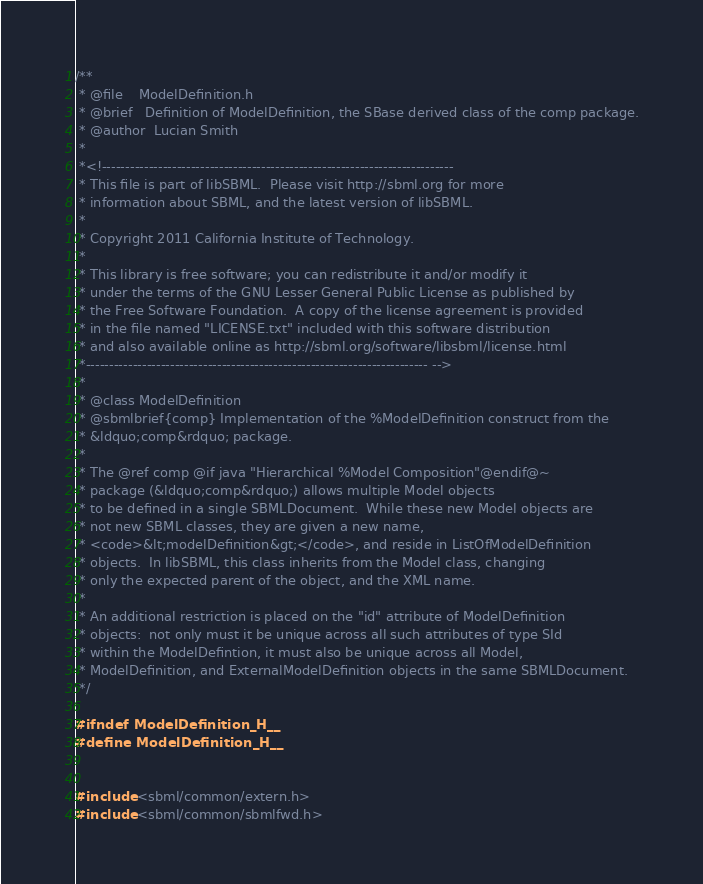<code> <loc_0><loc_0><loc_500><loc_500><_C_>/**
 * @file    ModelDefinition.h
 * @brief   Definition of ModelDefinition, the SBase derived class of the comp package.
 * @author  Lucian Smith 
 *
 *<!---------------------------------------------------------------------------
 * This file is part of libSBML.  Please visit http://sbml.org for more
 * information about SBML, and the latest version of libSBML.
 *
 * Copyright 2011 California Institute of Technology.
 * 
 * This library is free software; you can redistribute it and/or modify it
 * under the terms of the GNU Lesser General Public License as published by
 * the Free Software Foundation.  A copy of the license agreement is provided
 * in the file named "LICENSE.txt" included with this software distribution
 * and also available online as http://sbml.org/software/libsbml/license.html
 *------------------------------------------------------------------------- -->
 *
 * @class ModelDefinition
 * @sbmlbrief{comp} Implementation of the %ModelDefinition construct from the
 * &ldquo;comp&rdquo; package.
 *
 * The @ref comp @if java "Hierarchical %Model Composition"@endif@~ 
 * package (&ldquo;comp&rdquo;) allows multiple Model objects
 * to be defined in a single SBMLDocument.  While these new Model objects are
 * not new SBML classes, they are given a new name,
 * <code>&lt;modelDefinition&gt;</code>, and reside in ListOfModelDefinition
 * objects.  In libSBML, this class inherits from the Model class, changing
 * only the expected parent of the object, and the XML name.
 *
 * An additional restriction is placed on the "id" attribute of ModelDefinition
 * objects:  not only must it be unique across all such attributes of type SId 
 * within the ModelDefintion, it must also be unique across all Model, 
 * ModelDefinition, and ExternalModelDefinition objects in the same SBMLDocument.
 */

#ifndef ModelDefinition_H__
#define ModelDefinition_H__


#include <sbml/common/extern.h>
#include <sbml/common/sbmlfwd.h></code> 